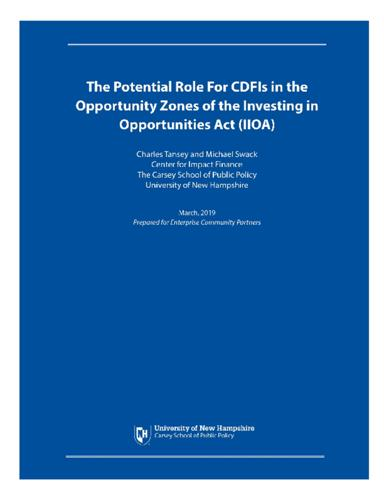Can you outline the core benefits of Opportunity Zones as discussed in this document? The document likely outlines that Opportunity Zones could offer tax incentives to investors, therefore attracting investments into regions that require economic growth and development. This initiative can help in bridging the economic gap in disadvantaged areas by boosting local businesses and creating jobs. Are there any potential drawbacks or challenges mentioned? While the document is optimistic about the benefits, it might also caution about potential challenges such as the risk of gentrification, where rising property values could displace long-term residents, or the uneven distribution of investment benefits, favoring investors over community members unless carefully managed. 